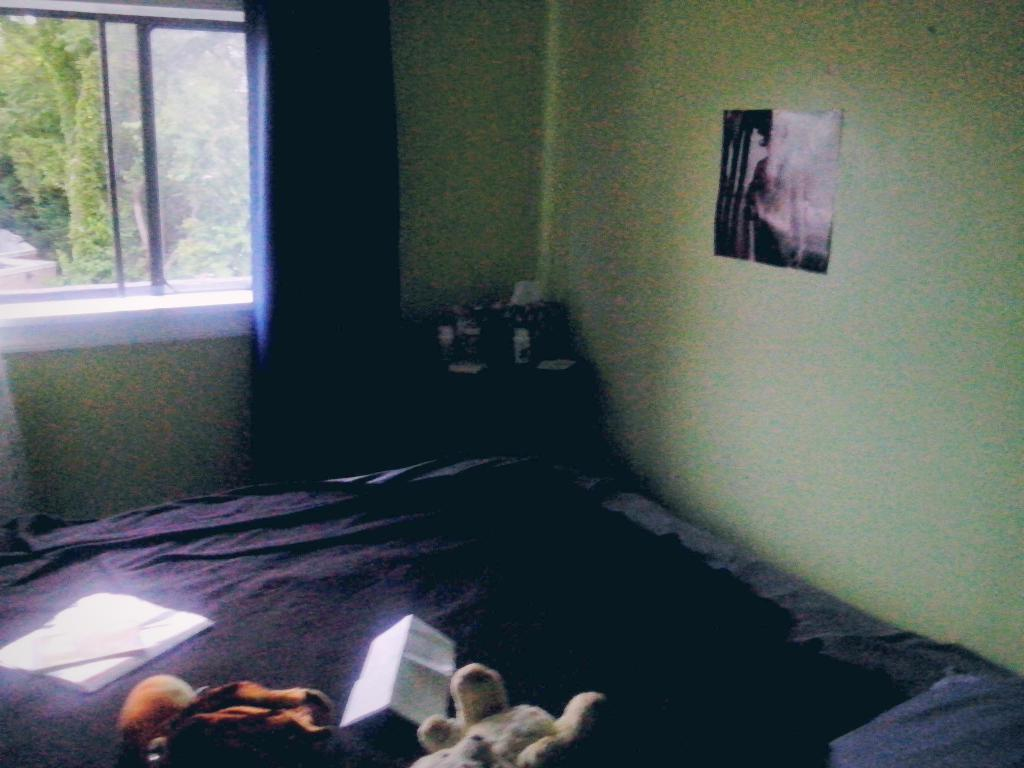What objects are on the bed in the image? There are dolls, at least one book, and some papers on the bed. Can you describe something on the wall? There is a poster on the wall. What can be seen through the window? Trees are visible through the window. Is there any window treatment present in the room? Yes, there is a curtain associated with the window. How does the room receive natural light? The room receives natural light through the window. What kind of vegetation is observable from inside the room? Trees are observable from inside the room. What letter is the farmer holding in the image? There is no farmer or letter present in the image. 